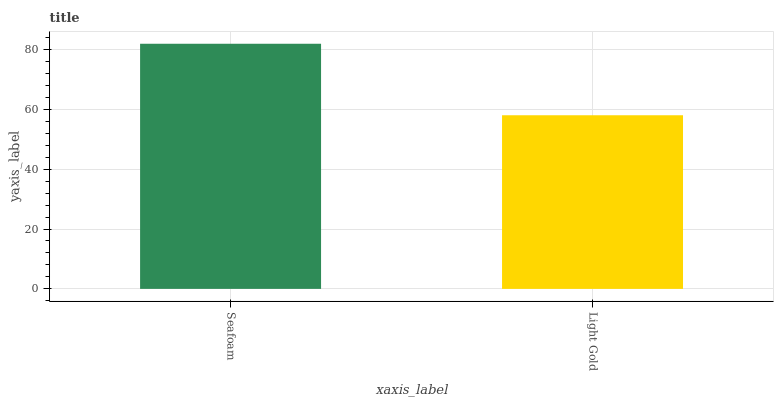Is Light Gold the minimum?
Answer yes or no. Yes. Is Seafoam the maximum?
Answer yes or no. Yes. Is Light Gold the maximum?
Answer yes or no. No. Is Seafoam greater than Light Gold?
Answer yes or no. Yes. Is Light Gold less than Seafoam?
Answer yes or no. Yes. Is Light Gold greater than Seafoam?
Answer yes or no. No. Is Seafoam less than Light Gold?
Answer yes or no. No. Is Seafoam the high median?
Answer yes or no. Yes. Is Light Gold the low median?
Answer yes or no. Yes. Is Light Gold the high median?
Answer yes or no. No. Is Seafoam the low median?
Answer yes or no. No. 